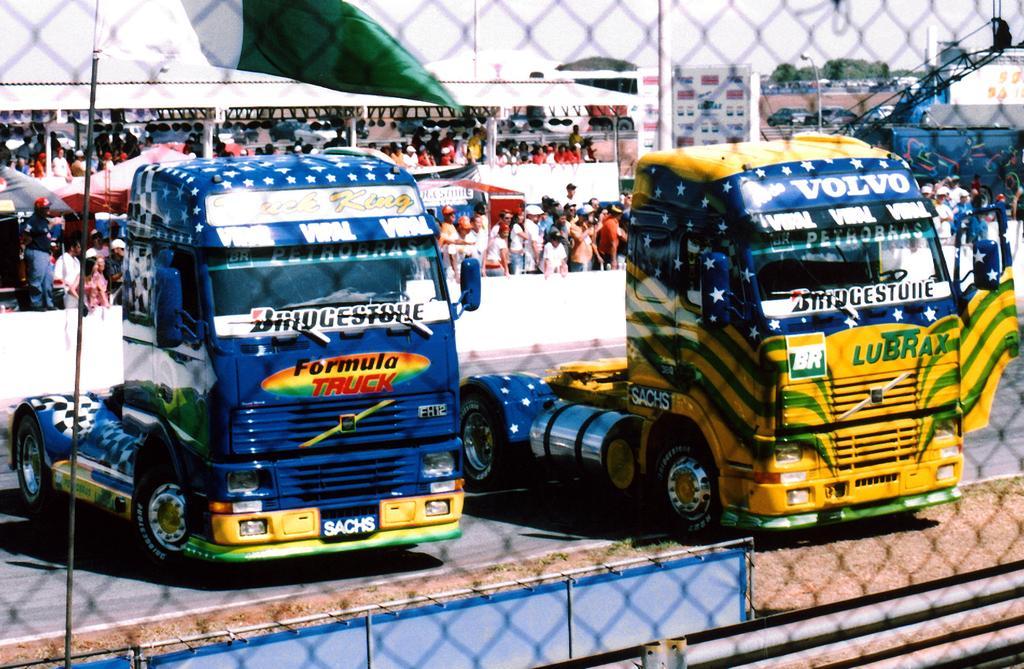In one or two sentences, can you explain what this image depicts? In this picture I can see there are two trucks and they are in two different colors like yellow and blue. There are having few stickers and in the backdrop I can see there is a huge crowd and there are trees and the sky is clear. 